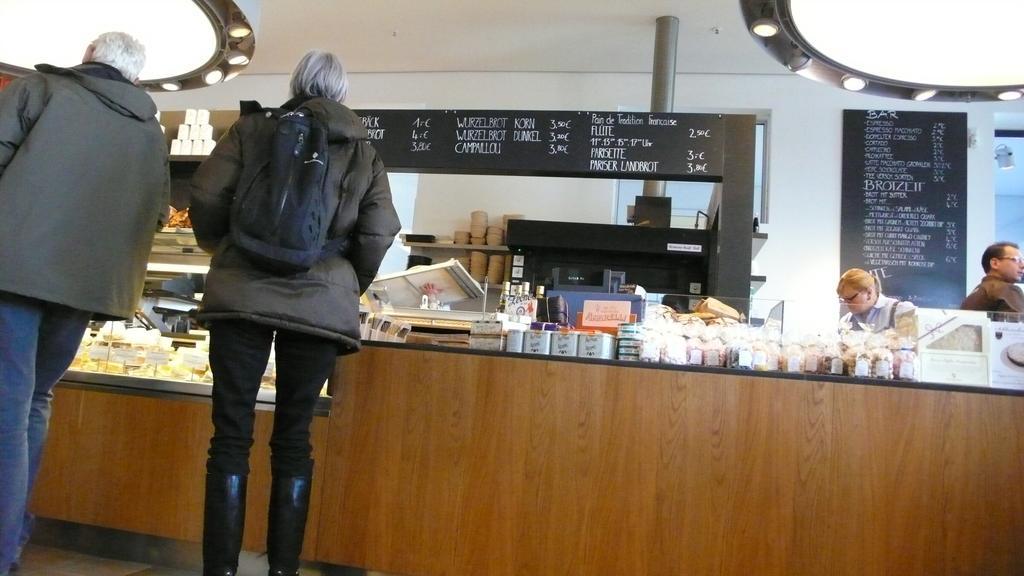In one or two sentences, can you explain what this image depicts? In this image, on the left side, we can see two people are standing in front of the table. On the table, we can see some objects and bottles are placed. On the right side, we can see two people are standing in front of the table. In the background, we can see a board with some text written on it, pillars. At the top, we can see a roof with few lights. 